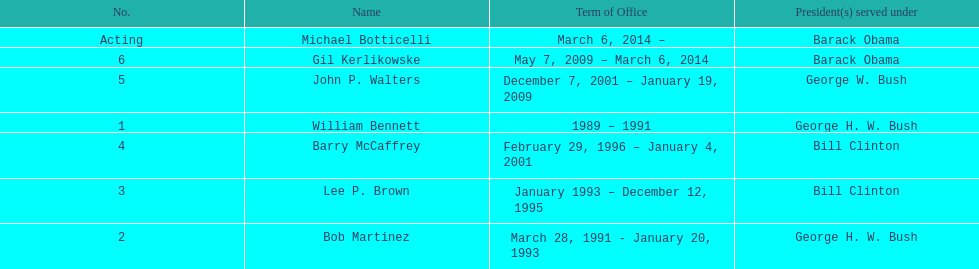Who was the next appointed director after lee p. brown? Barry McCaffrey. 